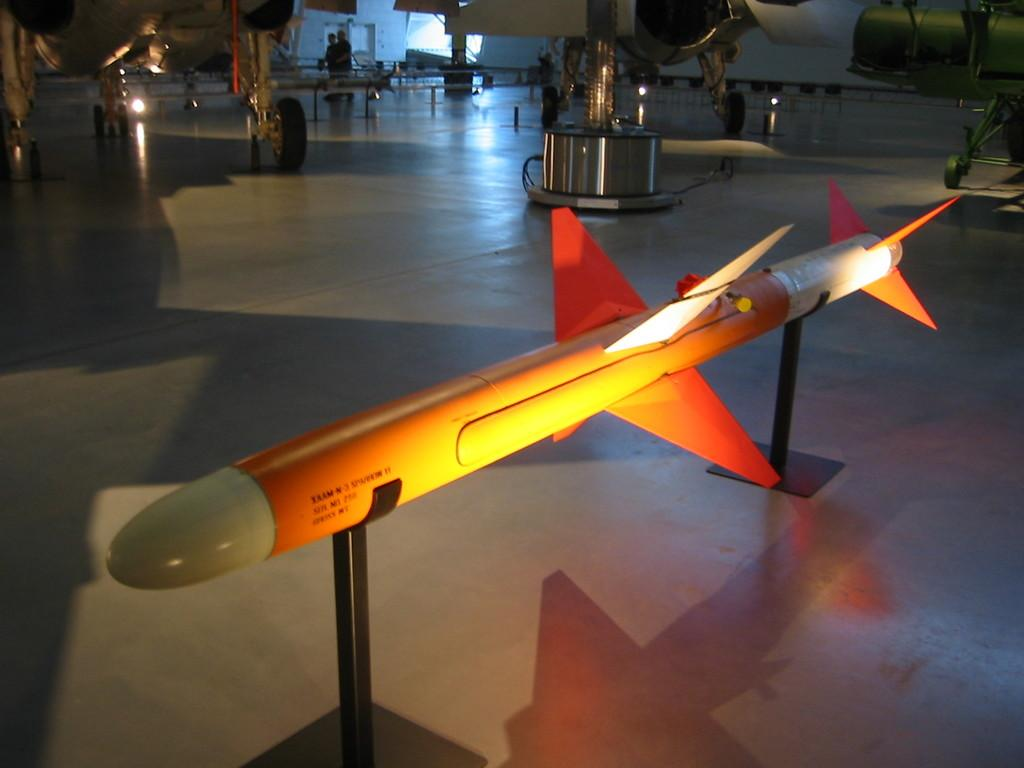What is the main subject of the image? The main subject of the image is a rocket missile. What is the rocket missile placed on? The rocket missile is on a black color object. What can be seen in the background of the image? In the background of the image, there are airplanes, people standing on the floor, and other objects. How much debt is the rocket missile incurring in the image? There is no information about debt in the image, as it features a rocket missile and related objects. --- Facts: 1. There is a person holding a book in the image. 2. The person is sitting on a chair. 3. The chair is in front of a table. 4. There is a lamp on the table. 5. The room has a wooden floor. Absurd Topics: elephant, ocean, dance Conversation: What is the person in the image doing? The person in the image is holding a book. Where is the person sitting? The person is sitting on a chair. What is the chair's position in relation to the table? The chair is in front of the table. What object is on the table? There is a lamp on the table. What type of flooring is in the room? The room has a wooden floor. Reasoning: Let's think step by step in order to produce the conversation. We start by identifying the main subject of the image, which is the person holding a book. Then, we describe the person's position and the objects around them, such as the chair, table, and lamp. Finally, we mention the type of flooring in the room, which is wooden. Absurd Question/Answer: Can you see any elephants swimming in the ocean in the image? There are no elephants or ocean visible in the image; it features a person reading a book in a room with a wooden floor. 